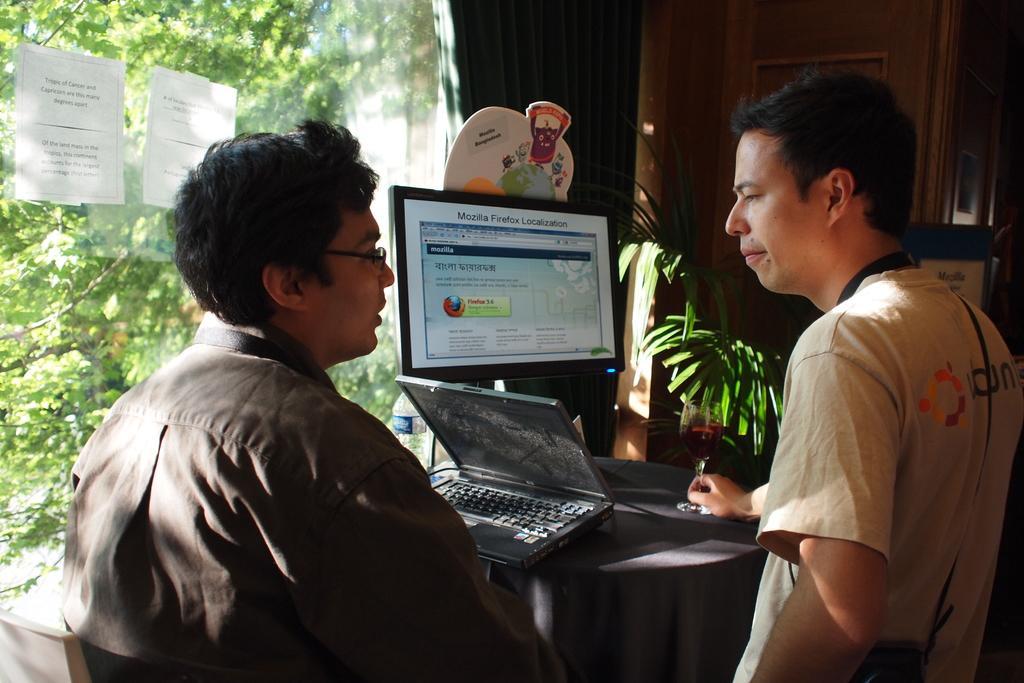How would you summarize this image in a sentence or two? In this image we can see two persons, among them one person is holding an object, in front them there is a table covered with the cloth, there is a laptop and system on the table, on the left side of the image we can see a mirror with some posters, through the mirror we can see some trees and in the background we can see the wall. 